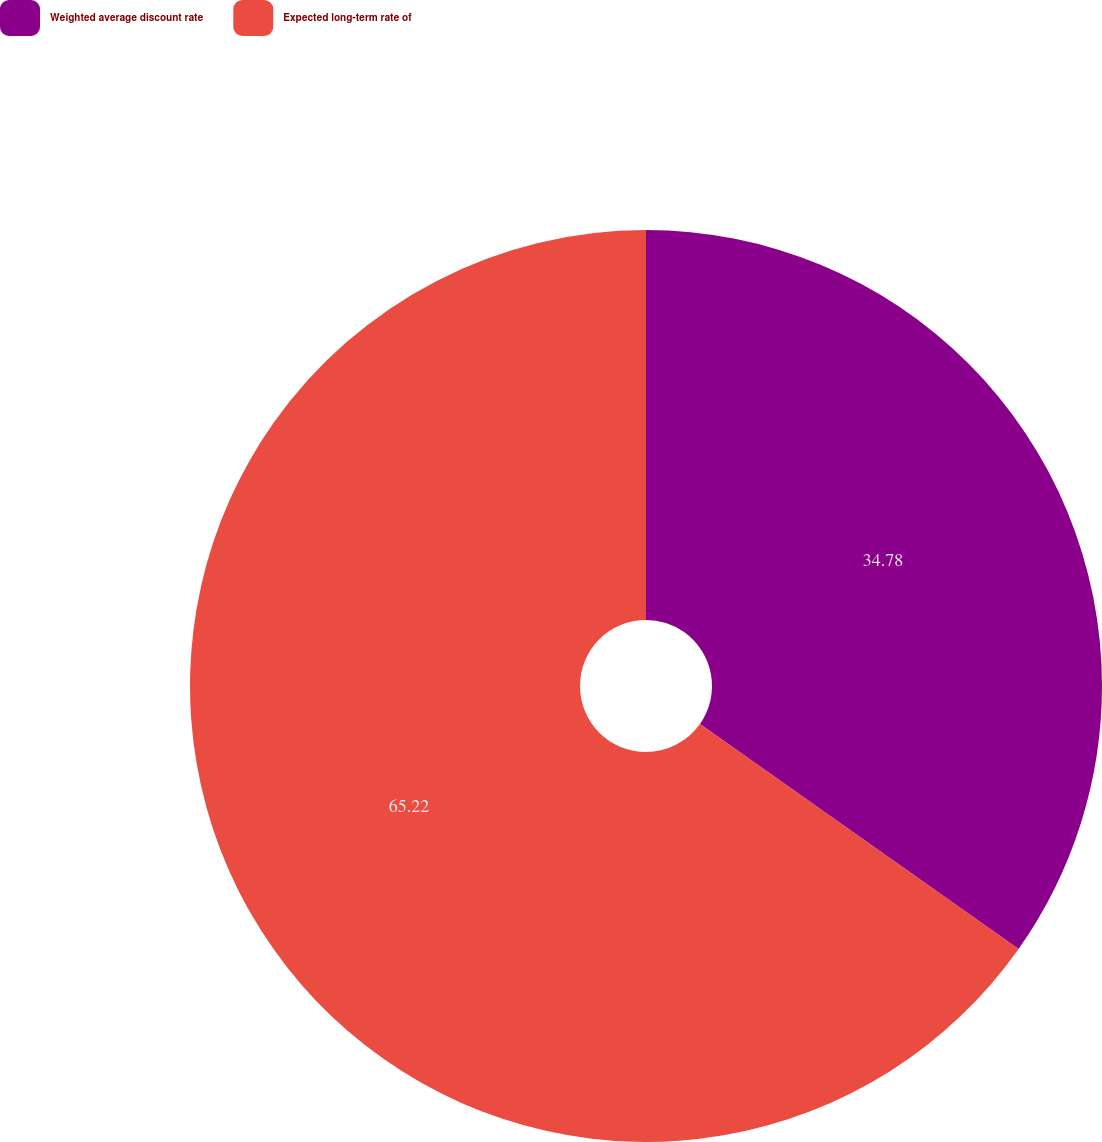<chart> <loc_0><loc_0><loc_500><loc_500><pie_chart><fcel>Weighted average discount rate<fcel>Expected long-term rate of<nl><fcel>34.78%<fcel>65.22%<nl></chart> 